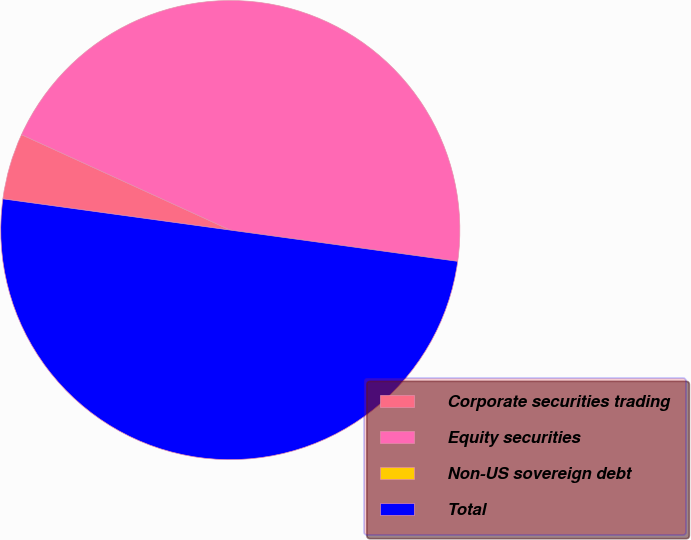<chart> <loc_0><loc_0><loc_500><loc_500><pie_chart><fcel>Corporate securities trading<fcel>Equity securities<fcel>Non-US sovereign debt<fcel>Total<nl><fcel>4.65%<fcel>45.35%<fcel>0.0%<fcel>50.0%<nl></chart> 